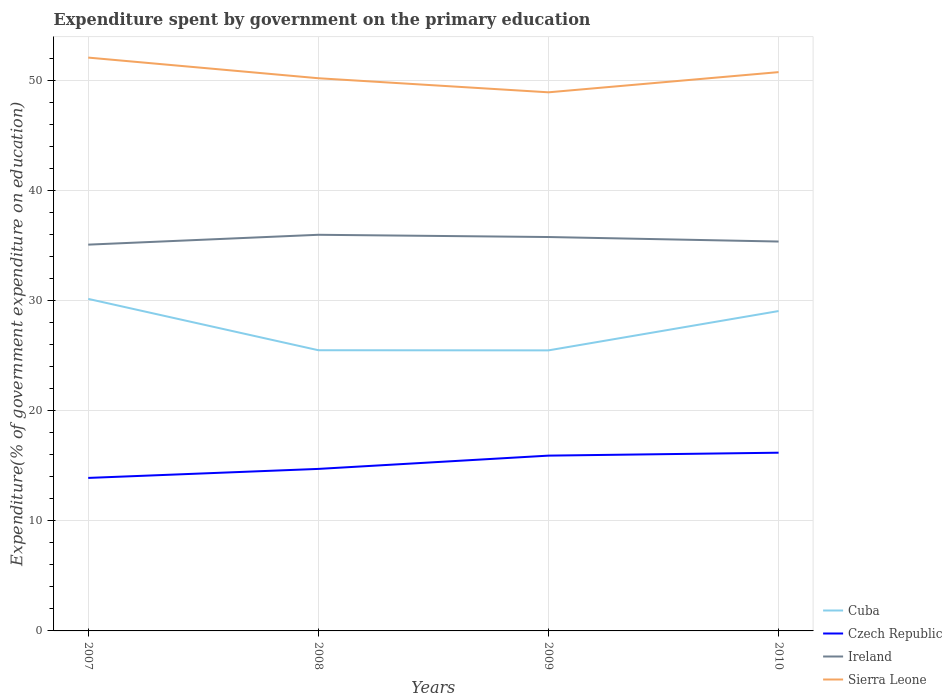How many different coloured lines are there?
Keep it short and to the point. 4. Is the number of lines equal to the number of legend labels?
Keep it short and to the point. Yes. Across all years, what is the maximum expenditure spent by government on the primary education in Ireland?
Make the answer very short. 35.06. What is the total expenditure spent by government on the primary education in Ireland in the graph?
Provide a short and direct response. -0.69. What is the difference between the highest and the second highest expenditure spent by government on the primary education in Sierra Leone?
Provide a succinct answer. 3.15. What is the difference between the highest and the lowest expenditure spent by government on the primary education in Ireland?
Provide a succinct answer. 2. Is the expenditure spent by government on the primary education in Ireland strictly greater than the expenditure spent by government on the primary education in Czech Republic over the years?
Offer a very short reply. No. Are the values on the major ticks of Y-axis written in scientific E-notation?
Your response must be concise. No. Does the graph contain any zero values?
Give a very brief answer. No. Where does the legend appear in the graph?
Your answer should be very brief. Bottom right. What is the title of the graph?
Offer a terse response. Expenditure spent by government on the primary education. What is the label or title of the X-axis?
Provide a succinct answer. Years. What is the label or title of the Y-axis?
Provide a succinct answer. Expenditure(% of government expenditure on education). What is the Expenditure(% of government expenditure on education) of Cuba in 2007?
Offer a very short reply. 30.14. What is the Expenditure(% of government expenditure on education) of Czech Republic in 2007?
Provide a short and direct response. 13.89. What is the Expenditure(% of government expenditure on education) of Ireland in 2007?
Provide a short and direct response. 35.06. What is the Expenditure(% of government expenditure on education) in Sierra Leone in 2007?
Ensure brevity in your answer.  52.04. What is the Expenditure(% of government expenditure on education) of Cuba in 2008?
Provide a short and direct response. 25.48. What is the Expenditure(% of government expenditure on education) of Czech Republic in 2008?
Give a very brief answer. 14.71. What is the Expenditure(% of government expenditure on education) of Ireland in 2008?
Your answer should be compact. 35.96. What is the Expenditure(% of government expenditure on education) of Sierra Leone in 2008?
Provide a short and direct response. 50.17. What is the Expenditure(% of government expenditure on education) of Cuba in 2009?
Provide a short and direct response. 25.47. What is the Expenditure(% of government expenditure on education) in Czech Republic in 2009?
Your response must be concise. 15.91. What is the Expenditure(% of government expenditure on education) of Ireland in 2009?
Offer a very short reply. 35.75. What is the Expenditure(% of government expenditure on education) of Sierra Leone in 2009?
Give a very brief answer. 48.89. What is the Expenditure(% of government expenditure on education) in Cuba in 2010?
Your response must be concise. 29.04. What is the Expenditure(% of government expenditure on education) in Czech Republic in 2010?
Give a very brief answer. 16.18. What is the Expenditure(% of government expenditure on education) in Ireland in 2010?
Provide a succinct answer. 35.35. What is the Expenditure(% of government expenditure on education) in Sierra Leone in 2010?
Your response must be concise. 50.72. Across all years, what is the maximum Expenditure(% of government expenditure on education) of Cuba?
Ensure brevity in your answer.  30.14. Across all years, what is the maximum Expenditure(% of government expenditure on education) in Czech Republic?
Keep it short and to the point. 16.18. Across all years, what is the maximum Expenditure(% of government expenditure on education) of Ireland?
Your answer should be very brief. 35.96. Across all years, what is the maximum Expenditure(% of government expenditure on education) in Sierra Leone?
Provide a short and direct response. 52.04. Across all years, what is the minimum Expenditure(% of government expenditure on education) in Cuba?
Provide a succinct answer. 25.47. Across all years, what is the minimum Expenditure(% of government expenditure on education) in Czech Republic?
Provide a succinct answer. 13.89. Across all years, what is the minimum Expenditure(% of government expenditure on education) of Ireland?
Your response must be concise. 35.06. Across all years, what is the minimum Expenditure(% of government expenditure on education) of Sierra Leone?
Provide a short and direct response. 48.89. What is the total Expenditure(% of government expenditure on education) of Cuba in the graph?
Keep it short and to the point. 110.12. What is the total Expenditure(% of government expenditure on education) of Czech Republic in the graph?
Offer a very short reply. 60.68. What is the total Expenditure(% of government expenditure on education) in Ireland in the graph?
Provide a short and direct response. 142.12. What is the total Expenditure(% of government expenditure on education) in Sierra Leone in the graph?
Ensure brevity in your answer.  201.82. What is the difference between the Expenditure(% of government expenditure on education) of Cuba in 2007 and that in 2008?
Make the answer very short. 4.66. What is the difference between the Expenditure(% of government expenditure on education) in Czech Republic in 2007 and that in 2008?
Offer a very short reply. -0.82. What is the difference between the Expenditure(% of government expenditure on education) of Ireland in 2007 and that in 2008?
Provide a short and direct response. -0.89. What is the difference between the Expenditure(% of government expenditure on education) in Sierra Leone in 2007 and that in 2008?
Keep it short and to the point. 1.87. What is the difference between the Expenditure(% of government expenditure on education) in Cuba in 2007 and that in 2009?
Provide a succinct answer. 4.67. What is the difference between the Expenditure(% of government expenditure on education) of Czech Republic in 2007 and that in 2009?
Give a very brief answer. -2.02. What is the difference between the Expenditure(% of government expenditure on education) in Ireland in 2007 and that in 2009?
Provide a succinct answer. -0.69. What is the difference between the Expenditure(% of government expenditure on education) of Sierra Leone in 2007 and that in 2009?
Offer a terse response. 3.15. What is the difference between the Expenditure(% of government expenditure on education) of Cuba in 2007 and that in 2010?
Offer a very short reply. 1.1. What is the difference between the Expenditure(% of government expenditure on education) in Czech Republic in 2007 and that in 2010?
Provide a short and direct response. -2.29. What is the difference between the Expenditure(% of government expenditure on education) of Ireland in 2007 and that in 2010?
Offer a terse response. -0.28. What is the difference between the Expenditure(% of government expenditure on education) in Sierra Leone in 2007 and that in 2010?
Your answer should be compact. 1.32. What is the difference between the Expenditure(% of government expenditure on education) of Cuba in 2008 and that in 2009?
Ensure brevity in your answer.  0.01. What is the difference between the Expenditure(% of government expenditure on education) in Czech Republic in 2008 and that in 2009?
Provide a succinct answer. -1.2. What is the difference between the Expenditure(% of government expenditure on education) of Ireland in 2008 and that in 2009?
Your answer should be compact. 0.2. What is the difference between the Expenditure(% of government expenditure on education) of Sierra Leone in 2008 and that in 2009?
Provide a short and direct response. 1.28. What is the difference between the Expenditure(% of government expenditure on education) of Cuba in 2008 and that in 2010?
Offer a terse response. -3.56. What is the difference between the Expenditure(% of government expenditure on education) in Czech Republic in 2008 and that in 2010?
Provide a short and direct response. -1.47. What is the difference between the Expenditure(% of government expenditure on education) of Ireland in 2008 and that in 2010?
Offer a very short reply. 0.61. What is the difference between the Expenditure(% of government expenditure on education) of Sierra Leone in 2008 and that in 2010?
Your response must be concise. -0.55. What is the difference between the Expenditure(% of government expenditure on education) in Cuba in 2009 and that in 2010?
Provide a succinct answer. -3.57. What is the difference between the Expenditure(% of government expenditure on education) of Czech Republic in 2009 and that in 2010?
Ensure brevity in your answer.  -0.27. What is the difference between the Expenditure(% of government expenditure on education) in Ireland in 2009 and that in 2010?
Ensure brevity in your answer.  0.41. What is the difference between the Expenditure(% of government expenditure on education) in Sierra Leone in 2009 and that in 2010?
Offer a very short reply. -1.83. What is the difference between the Expenditure(% of government expenditure on education) of Cuba in 2007 and the Expenditure(% of government expenditure on education) of Czech Republic in 2008?
Offer a terse response. 15.43. What is the difference between the Expenditure(% of government expenditure on education) of Cuba in 2007 and the Expenditure(% of government expenditure on education) of Ireland in 2008?
Provide a short and direct response. -5.82. What is the difference between the Expenditure(% of government expenditure on education) of Cuba in 2007 and the Expenditure(% of government expenditure on education) of Sierra Leone in 2008?
Give a very brief answer. -20.03. What is the difference between the Expenditure(% of government expenditure on education) in Czech Republic in 2007 and the Expenditure(% of government expenditure on education) in Ireland in 2008?
Give a very brief answer. -22.07. What is the difference between the Expenditure(% of government expenditure on education) of Czech Republic in 2007 and the Expenditure(% of government expenditure on education) of Sierra Leone in 2008?
Give a very brief answer. -36.28. What is the difference between the Expenditure(% of government expenditure on education) in Ireland in 2007 and the Expenditure(% of government expenditure on education) in Sierra Leone in 2008?
Offer a very short reply. -15.11. What is the difference between the Expenditure(% of government expenditure on education) in Cuba in 2007 and the Expenditure(% of government expenditure on education) in Czech Republic in 2009?
Provide a succinct answer. 14.23. What is the difference between the Expenditure(% of government expenditure on education) of Cuba in 2007 and the Expenditure(% of government expenditure on education) of Ireland in 2009?
Your answer should be compact. -5.62. What is the difference between the Expenditure(% of government expenditure on education) in Cuba in 2007 and the Expenditure(% of government expenditure on education) in Sierra Leone in 2009?
Your answer should be very brief. -18.75. What is the difference between the Expenditure(% of government expenditure on education) of Czech Republic in 2007 and the Expenditure(% of government expenditure on education) of Ireland in 2009?
Provide a short and direct response. -21.87. What is the difference between the Expenditure(% of government expenditure on education) in Czech Republic in 2007 and the Expenditure(% of government expenditure on education) in Sierra Leone in 2009?
Offer a terse response. -35. What is the difference between the Expenditure(% of government expenditure on education) of Ireland in 2007 and the Expenditure(% of government expenditure on education) of Sierra Leone in 2009?
Your answer should be very brief. -13.83. What is the difference between the Expenditure(% of government expenditure on education) of Cuba in 2007 and the Expenditure(% of government expenditure on education) of Czech Republic in 2010?
Provide a short and direct response. 13.96. What is the difference between the Expenditure(% of government expenditure on education) of Cuba in 2007 and the Expenditure(% of government expenditure on education) of Ireland in 2010?
Your answer should be very brief. -5.21. What is the difference between the Expenditure(% of government expenditure on education) of Cuba in 2007 and the Expenditure(% of government expenditure on education) of Sierra Leone in 2010?
Make the answer very short. -20.58. What is the difference between the Expenditure(% of government expenditure on education) in Czech Republic in 2007 and the Expenditure(% of government expenditure on education) in Ireland in 2010?
Your answer should be very brief. -21.46. What is the difference between the Expenditure(% of government expenditure on education) in Czech Republic in 2007 and the Expenditure(% of government expenditure on education) in Sierra Leone in 2010?
Keep it short and to the point. -36.84. What is the difference between the Expenditure(% of government expenditure on education) in Ireland in 2007 and the Expenditure(% of government expenditure on education) in Sierra Leone in 2010?
Provide a succinct answer. -15.66. What is the difference between the Expenditure(% of government expenditure on education) in Cuba in 2008 and the Expenditure(% of government expenditure on education) in Czech Republic in 2009?
Your answer should be compact. 9.57. What is the difference between the Expenditure(% of government expenditure on education) in Cuba in 2008 and the Expenditure(% of government expenditure on education) in Ireland in 2009?
Your response must be concise. -10.28. What is the difference between the Expenditure(% of government expenditure on education) of Cuba in 2008 and the Expenditure(% of government expenditure on education) of Sierra Leone in 2009?
Your response must be concise. -23.41. What is the difference between the Expenditure(% of government expenditure on education) of Czech Republic in 2008 and the Expenditure(% of government expenditure on education) of Ireland in 2009?
Offer a very short reply. -21.05. What is the difference between the Expenditure(% of government expenditure on education) in Czech Republic in 2008 and the Expenditure(% of government expenditure on education) in Sierra Leone in 2009?
Your answer should be very brief. -34.18. What is the difference between the Expenditure(% of government expenditure on education) in Ireland in 2008 and the Expenditure(% of government expenditure on education) in Sierra Leone in 2009?
Make the answer very short. -12.93. What is the difference between the Expenditure(% of government expenditure on education) in Cuba in 2008 and the Expenditure(% of government expenditure on education) in Czech Republic in 2010?
Your answer should be compact. 9.3. What is the difference between the Expenditure(% of government expenditure on education) of Cuba in 2008 and the Expenditure(% of government expenditure on education) of Ireland in 2010?
Provide a succinct answer. -9.87. What is the difference between the Expenditure(% of government expenditure on education) of Cuba in 2008 and the Expenditure(% of government expenditure on education) of Sierra Leone in 2010?
Keep it short and to the point. -25.24. What is the difference between the Expenditure(% of government expenditure on education) in Czech Republic in 2008 and the Expenditure(% of government expenditure on education) in Ireland in 2010?
Keep it short and to the point. -20.64. What is the difference between the Expenditure(% of government expenditure on education) of Czech Republic in 2008 and the Expenditure(% of government expenditure on education) of Sierra Leone in 2010?
Your answer should be very brief. -36.02. What is the difference between the Expenditure(% of government expenditure on education) in Ireland in 2008 and the Expenditure(% of government expenditure on education) in Sierra Leone in 2010?
Your answer should be compact. -14.77. What is the difference between the Expenditure(% of government expenditure on education) in Cuba in 2009 and the Expenditure(% of government expenditure on education) in Czech Republic in 2010?
Provide a short and direct response. 9.29. What is the difference between the Expenditure(% of government expenditure on education) of Cuba in 2009 and the Expenditure(% of government expenditure on education) of Ireland in 2010?
Provide a short and direct response. -9.88. What is the difference between the Expenditure(% of government expenditure on education) of Cuba in 2009 and the Expenditure(% of government expenditure on education) of Sierra Leone in 2010?
Make the answer very short. -25.26. What is the difference between the Expenditure(% of government expenditure on education) of Czech Republic in 2009 and the Expenditure(% of government expenditure on education) of Ireland in 2010?
Provide a short and direct response. -19.43. What is the difference between the Expenditure(% of government expenditure on education) in Czech Republic in 2009 and the Expenditure(% of government expenditure on education) in Sierra Leone in 2010?
Keep it short and to the point. -34.81. What is the difference between the Expenditure(% of government expenditure on education) in Ireland in 2009 and the Expenditure(% of government expenditure on education) in Sierra Leone in 2010?
Keep it short and to the point. -14.97. What is the average Expenditure(% of government expenditure on education) in Cuba per year?
Your answer should be very brief. 27.53. What is the average Expenditure(% of government expenditure on education) in Czech Republic per year?
Offer a terse response. 15.17. What is the average Expenditure(% of government expenditure on education) of Ireland per year?
Give a very brief answer. 35.53. What is the average Expenditure(% of government expenditure on education) of Sierra Leone per year?
Your response must be concise. 50.46. In the year 2007, what is the difference between the Expenditure(% of government expenditure on education) in Cuba and Expenditure(% of government expenditure on education) in Czech Republic?
Offer a terse response. 16.25. In the year 2007, what is the difference between the Expenditure(% of government expenditure on education) in Cuba and Expenditure(% of government expenditure on education) in Ireland?
Keep it short and to the point. -4.92. In the year 2007, what is the difference between the Expenditure(% of government expenditure on education) of Cuba and Expenditure(% of government expenditure on education) of Sierra Leone?
Ensure brevity in your answer.  -21.9. In the year 2007, what is the difference between the Expenditure(% of government expenditure on education) of Czech Republic and Expenditure(% of government expenditure on education) of Ireland?
Ensure brevity in your answer.  -21.18. In the year 2007, what is the difference between the Expenditure(% of government expenditure on education) in Czech Republic and Expenditure(% of government expenditure on education) in Sierra Leone?
Offer a terse response. -38.15. In the year 2007, what is the difference between the Expenditure(% of government expenditure on education) of Ireland and Expenditure(% of government expenditure on education) of Sierra Leone?
Your response must be concise. -16.98. In the year 2008, what is the difference between the Expenditure(% of government expenditure on education) of Cuba and Expenditure(% of government expenditure on education) of Czech Republic?
Your answer should be very brief. 10.77. In the year 2008, what is the difference between the Expenditure(% of government expenditure on education) in Cuba and Expenditure(% of government expenditure on education) in Ireland?
Keep it short and to the point. -10.48. In the year 2008, what is the difference between the Expenditure(% of government expenditure on education) of Cuba and Expenditure(% of government expenditure on education) of Sierra Leone?
Provide a succinct answer. -24.69. In the year 2008, what is the difference between the Expenditure(% of government expenditure on education) of Czech Republic and Expenditure(% of government expenditure on education) of Ireland?
Your answer should be very brief. -21.25. In the year 2008, what is the difference between the Expenditure(% of government expenditure on education) in Czech Republic and Expenditure(% of government expenditure on education) in Sierra Leone?
Offer a very short reply. -35.46. In the year 2008, what is the difference between the Expenditure(% of government expenditure on education) of Ireland and Expenditure(% of government expenditure on education) of Sierra Leone?
Give a very brief answer. -14.21. In the year 2009, what is the difference between the Expenditure(% of government expenditure on education) in Cuba and Expenditure(% of government expenditure on education) in Czech Republic?
Provide a short and direct response. 9.55. In the year 2009, what is the difference between the Expenditure(% of government expenditure on education) in Cuba and Expenditure(% of government expenditure on education) in Ireland?
Your answer should be compact. -10.29. In the year 2009, what is the difference between the Expenditure(% of government expenditure on education) in Cuba and Expenditure(% of government expenditure on education) in Sierra Leone?
Your answer should be very brief. -23.42. In the year 2009, what is the difference between the Expenditure(% of government expenditure on education) in Czech Republic and Expenditure(% of government expenditure on education) in Ireland?
Offer a terse response. -19.84. In the year 2009, what is the difference between the Expenditure(% of government expenditure on education) in Czech Republic and Expenditure(% of government expenditure on education) in Sierra Leone?
Give a very brief answer. -32.98. In the year 2009, what is the difference between the Expenditure(% of government expenditure on education) in Ireland and Expenditure(% of government expenditure on education) in Sierra Leone?
Offer a terse response. -13.14. In the year 2010, what is the difference between the Expenditure(% of government expenditure on education) in Cuba and Expenditure(% of government expenditure on education) in Czech Republic?
Provide a succinct answer. 12.86. In the year 2010, what is the difference between the Expenditure(% of government expenditure on education) in Cuba and Expenditure(% of government expenditure on education) in Ireland?
Give a very brief answer. -6.31. In the year 2010, what is the difference between the Expenditure(% of government expenditure on education) of Cuba and Expenditure(% of government expenditure on education) of Sierra Leone?
Provide a succinct answer. -21.69. In the year 2010, what is the difference between the Expenditure(% of government expenditure on education) of Czech Republic and Expenditure(% of government expenditure on education) of Ireland?
Ensure brevity in your answer.  -19.17. In the year 2010, what is the difference between the Expenditure(% of government expenditure on education) in Czech Republic and Expenditure(% of government expenditure on education) in Sierra Leone?
Provide a succinct answer. -34.55. In the year 2010, what is the difference between the Expenditure(% of government expenditure on education) of Ireland and Expenditure(% of government expenditure on education) of Sierra Leone?
Your answer should be very brief. -15.38. What is the ratio of the Expenditure(% of government expenditure on education) of Cuba in 2007 to that in 2008?
Ensure brevity in your answer.  1.18. What is the ratio of the Expenditure(% of government expenditure on education) in Czech Republic in 2007 to that in 2008?
Keep it short and to the point. 0.94. What is the ratio of the Expenditure(% of government expenditure on education) of Ireland in 2007 to that in 2008?
Your response must be concise. 0.98. What is the ratio of the Expenditure(% of government expenditure on education) in Sierra Leone in 2007 to that in 2008?
Provide a succinct answer. 1.04. What is the ratio of the Expenditure(% of government expenditure on education) in Cuba in 2007 to that in 2009?
Your answer should be very brief. 1.18. What is the ratio of the Expenditure(% of government expenditure on education) of Czech Republic in 2007 to that in 2009?
Make the answer very short. 0.87. What is the ratio of the Expenditure(% of government expenditure on education) of Ireland in 2007 to that in 2009?
Provide a short and direct response. 0.98. What is the ratio of the Expenditure(% of government expenditure on education) in Sierra Leone in 2007 to that in 2009?
Your answer should be very brief. 1.06. What is the ratio of the Expenditure(% of government expenditure on education) of Cuba in 2007 to that in 2010?
Ensure brevity in your answer.  1.04. What is the ratio of the Expenditure(% of government expenditure on education) in Czech Republic in 2007 to that in 2010?
Keep it short and to the point. 0.86. What is the ratio of the Expenditure(% of government expenditure on education) of Ireland in 2007 to that in 2010?
Make the answer very short. 0.99. What is the ratio of the Expenditure(% of government expenditure on education) in Czech Republic in 2008 to that in 2009?
Your answer should be very brief. 0.92. What is the ratio of the Expenditure(% of government expenditure on education) of Sierra Leone in 2008 to that in 2009?
Your answer should be very brief. 1.03. What is the ratio of the Expenditure(% of government expenditure on education) in Cuba in 2008 to that in 2010?
Provide a short and direct response. 0.88. What is the ratio of the Expenditure(% of government expenditure on education) in Ireland in 2008 to that in 2010?
Provide a succinct answer. 1.02. What is the ratio of the Expenditure(% of government expenditure on education) of Cuba in 2009 to that in 2010?
Keep it short and to the point. 0.88. What is the ratio of the Expenditure(% of government expenditure on education) of Czech Republic in 2009 to that in 2010?
Ensure brevity in your answer.  0.98. What is the ratio of the Expenditure(% of government expenditure on education) in Ireland in 2009 to that in 2010?
Offer a terse response. 1.01. What is the ratio of the Expenditure(% of government expenditure on education) in Sierra Leone in 2009 to that in 2010?
Provide a short and direct response. 0.96. What is the difference between the highest and the second highest Expenditure(% of government expenditure on education) in Cuba?
Your answer should be compact. 1.1. What is the difference between the highest and the second highest Expenditure(% of government expenditure on education) in Czech Republic?
Offer a very short reply. 0.27. What is the difference between the highest and the second highest Expenditure(% of government expenditure on education) in Ireland?
Keep it short and to the point. 0.2. What is the difference between the highest and the second highest Expenditure(% of government expenditure on education) of Sierra Leone?
Make the answer very short. 1.32. What is the difference between the highest and the lowest Expenditure(% of government expenditure on education) of Cuba?
Your answer should be very brief. 4.67. What is the difference between the highest and the lowest Expenditure(% of government expenditure on education) in Czech Republic?
Your answer should be very brief. 2.29. What is the difference between the highest and the lowest Expenditure(% of government expenditure on education) in Ireland?
Make the answer very short. 0.89. What is the difference between the highest and the lowest Expenditure(% of government expenditure on education) of Sierra Leone?
Your answer should be compact. 3.15. 